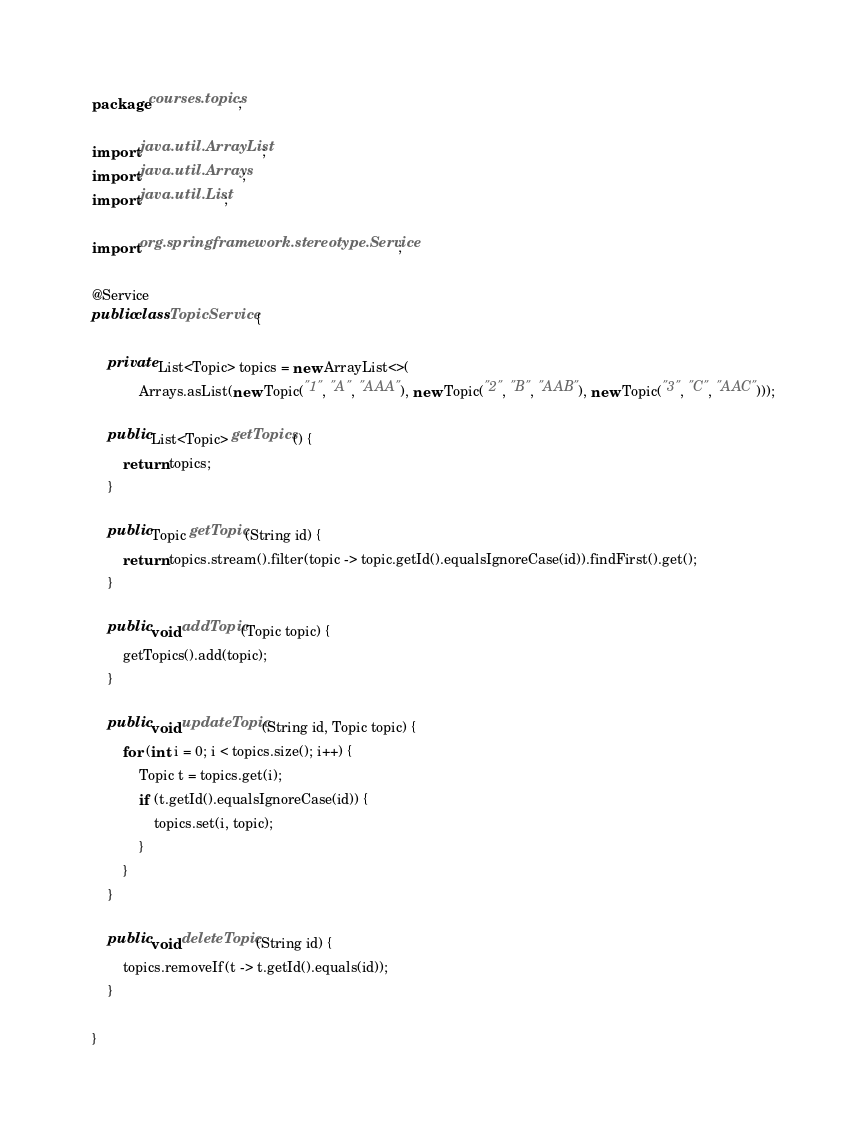<code> <loc_0><loc_0><loc_500><loc_500><_Java_>package courses.topics;

import java.util.ArrayList;
import java.util.Arrays;
import java.util.List;

import org.springframework.stereotype.Service;

@Service
public class TopicService {

	private List<Topic> topics = new ArrayList<>(
			Arrays.asList(new Topic("1", "A", "AAA"), new Topic("2", "B", "AAB"), new Topic("3", "C", "AAC")));

	public List<Topic> getTopics() {
		return topics;
	}

	public Topic getTopic(String id) {
		return topics.stream().filter(topic -> topic.getId().equalsIgnoreCase(id)).findFirst().get();
	}

	public void addTopic(Topic topic) {
		getTopics().add(topic);
	}

	public void updateTopic(String id, Topic topic) {
		for (int i = 0; i < topics.size(); i++) {
			Topic t = topics.get(i);
			if (t.getId().equalsIgnoreCase(id)) {
				topics.set(i, topic);
			}
		}
	}

	public void deleteTopic(String id) {
		topics.removeIf(t -> t.getId().equals(id));
	}

}
</code> 